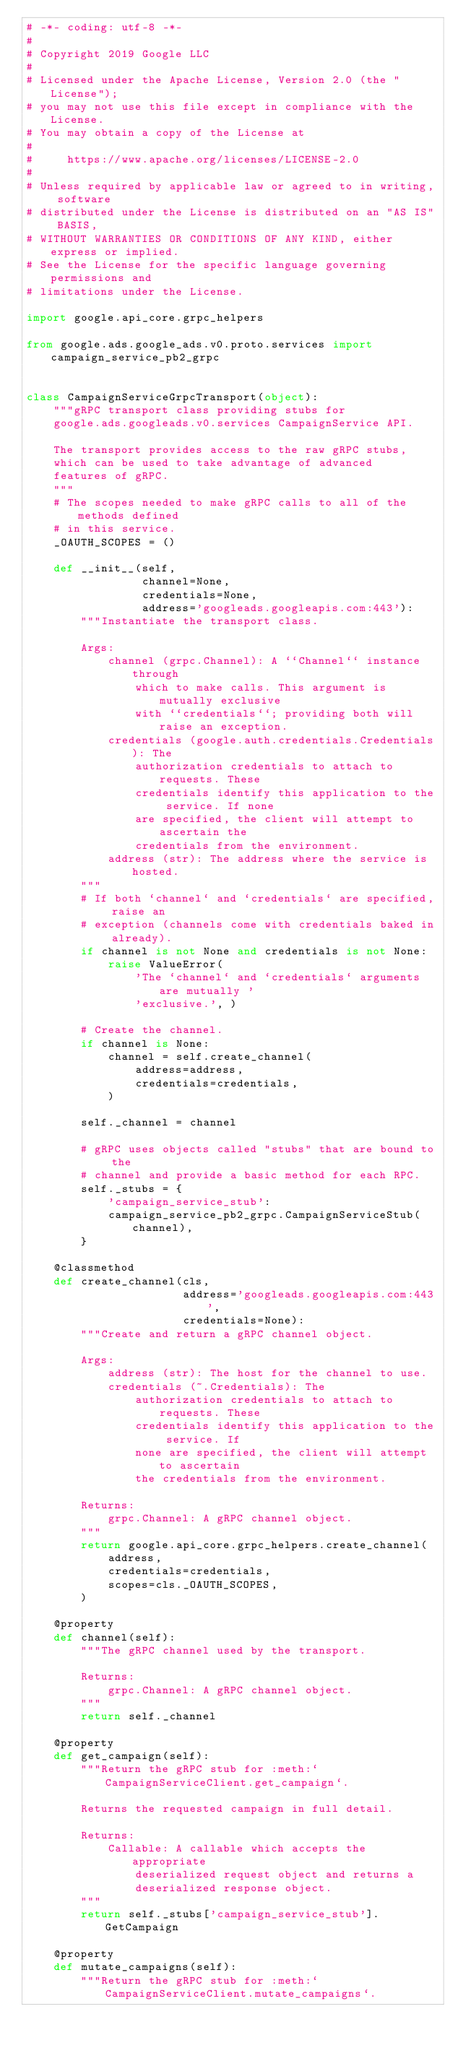Convert code to text. <code><loc_0><loc_0><loc_500><loc_500><_Python_># -*- coding: utf-8 -*-
#
# Copyright 2019 Google LLC
#
# Licensed under the Apache License, Version 2.0 (the "License");
# you may not use this file except in compliance with the License.
# You may obtain a copy of the License at
#
#     https://www.apache.org/licenses/LICENSE-2.0
#
# Unless required by applicable law or agreed to in writing, software
# distributed under the License is distributed on an "AS IS" BASIS,
# WITHOUT WARRANTIES OR CONDITIONS OF ANY KIND, either express or implied.
# See the License for the specific language governing permissions and
# limitations under the License.

import google.api_core.grpc_helpers

from google.ads.google_ads.v0.proto.services import campaign_service_pb2_grpc


class CampaignServiceGrpcTransport(object):
    """gRPC transport class providing stubs for
    google.ads.googleads.v0.services CampaignService API.

    The transport provides access to the raw gRPC stubs,
    which can be used to take advantage of advanced
    features of gRPC.
    """
    # The scopes needed to make gRPC calls to all of the methods defined
    # in this service.
    _OAUTH_SCOPES = ()

    def __init__(self,
                 channel=None,
                 credentials=None,
                 address='googleads.googleapis.com:443'):
        """Instantiate the transport class.

        Args:
            channel (grpc.Channel): A ``Channel`` instance through
                which to make calls. This argument is mutually exclusive
                with ``credentials``; providing both will raise an exception.
            credentials (google.auth.credentials.Credentials): The
                authorization credentials to attach to requests. These
                credentials identify this application to the service. If none
                are specified, the client will attempt to ascertain the
                credentials from the environment.
            address (str): The address where the service is hosted.
        """
        # If both `channel` and `credentials` are specified, raise an
        # exception (channels come with credentials baked in already).
        if channel is not None and credentials is not None:
            raise ValueError(
                'The `channel` and `credentials` arguments are mutually '
                'exclusive.', )

        # Create the channel.
        if channel is None:
            channel = self.create_channel(
                address=address,
                credentials=credentials,
            )

        self._channel = channel

        # gRPC uses objects called "stubs" that are bound to the
        # channel and provide a basic method for each RPC.
        self._stubs = {
            'campaign_service_stub':
            campaign_service_pb2_grpc.CampaignServiceStub(channel),
        }

    @classmethod
    def create_channel(cls,
                       address='googleads.googleapis.com:443',
                       credentials=None):
        """Create and return a gRPC channel object.

        Args:
            address (str): The host for the channel to use.
            credentials (~.Credentials): The
                authorization credentials to attach to requests. These
                credentials identify this application to the service. If
                none are specified, the client will attempt to ascertain
                the credentials from the environment.

        Returns:
            grpc.Channel: A gRPC channel object.
        """
        return google.api_core.grpc_helpers.create_channel(
            address,
            credentials=credentials,
            scopes=cls._OAUTH_SCOPES,
        )

    @property
    def channel(self):
        """The gRPC channel used by the transport.

        Returns:
            grpc.Channel: A gRPC channel object.
        """
        return self._channel

    @property
    def get_campaign(self):
        """Return the gRPC stub for :meth:`CampaignServiceClient.get_campaign`.

        Returns the requested campaign in full detail.

        Returns:
            Callable: A callable which accepts the appropriate
                deserialized request object and returns a
                deserialized response object.
        """
        return self._stubs['campaign_service_stub'].GetCampaign

    @property
    def mutate_campaigns(self):
        """Return the gRPC stub for :meth:`CampaignServiceClient.mutate_campaigns`.
</code> 